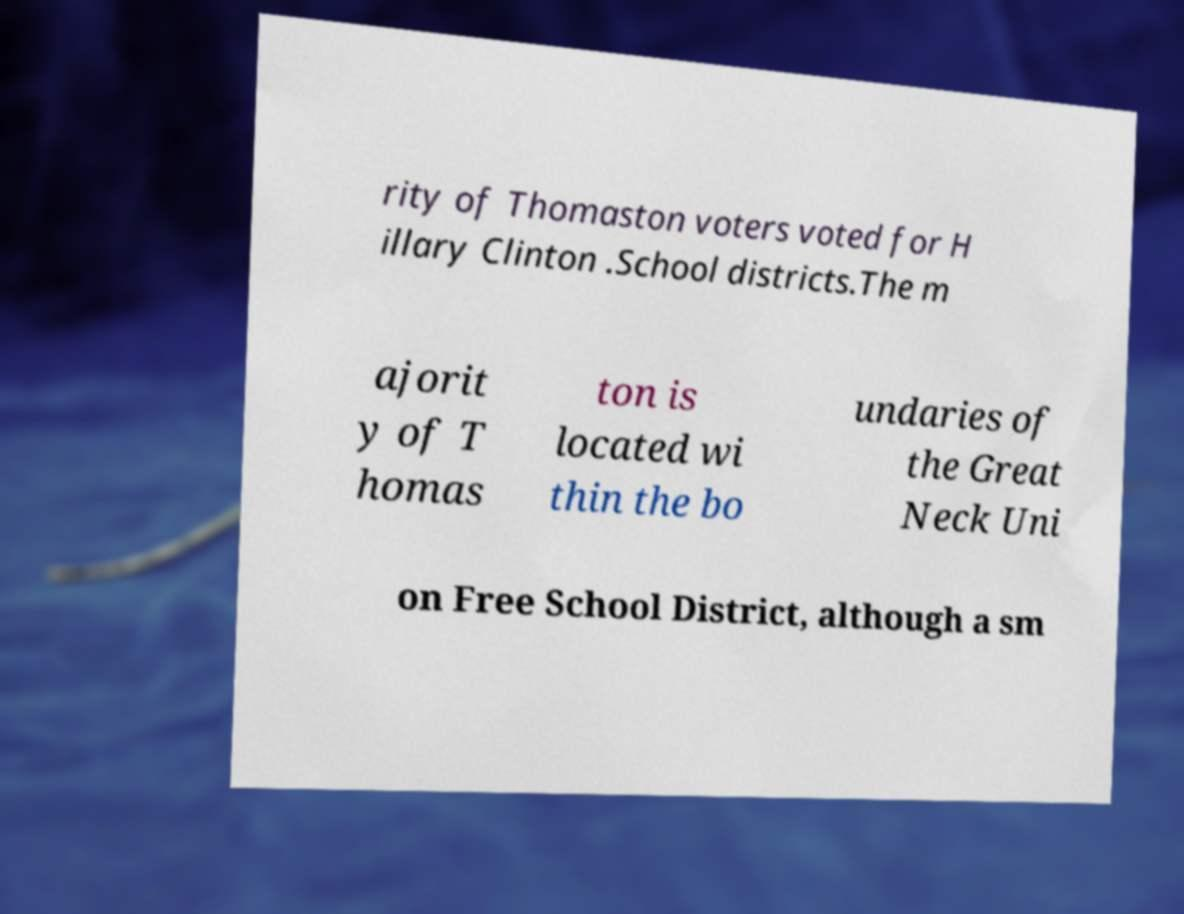Can you read and provide the text displayed in the image?This photo seems to have some interesting text. Can you extract and type it out for me? rity of Thomaston voters voted for H illary Clinton .School districts.The m ajorit y of T homas ton is located wi thin the bo undaries of the Great Neck Uni on Free School District, although a sm 